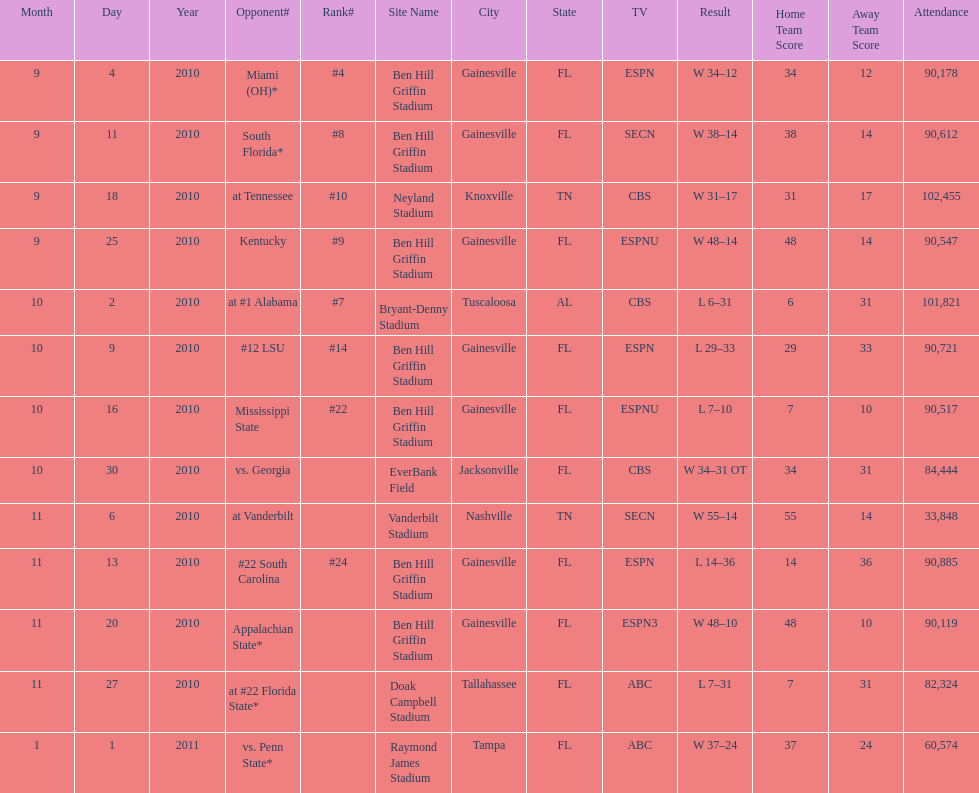How many games did the university of florida win by at least 10 points? 7. 